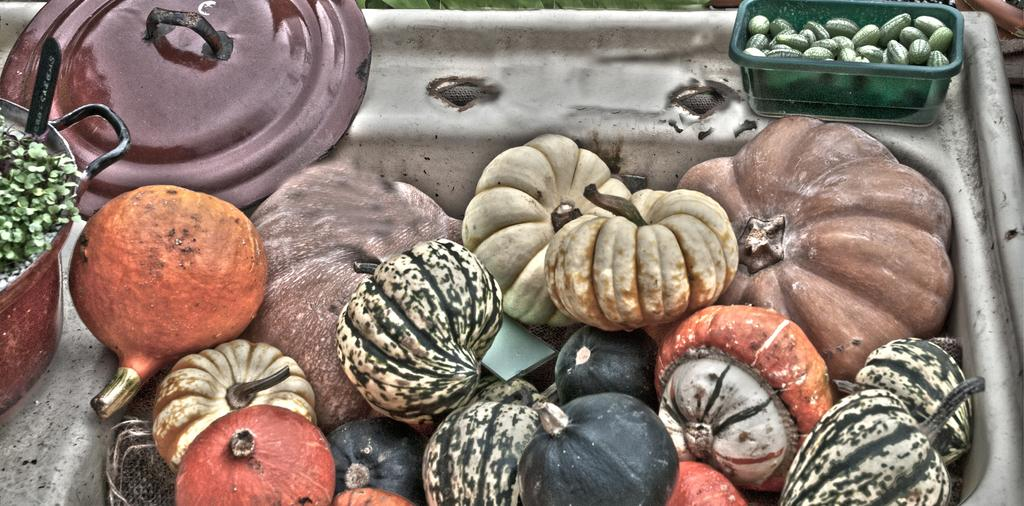What types of food items can be seen in the image? There are different types of vegetables in the image. Where is the vessel located in the image? The vessel is on the left side of the image. What is present in the top left corner of the image? There is a lid in the left-hand top corner of the image. Can you tell me how many streams are visible in the image? There are no streams present in the image; it features vegetables and a vessel with a lid. What type of teaching is being conducted in the image? There is no teaching activity depicted in the image. 